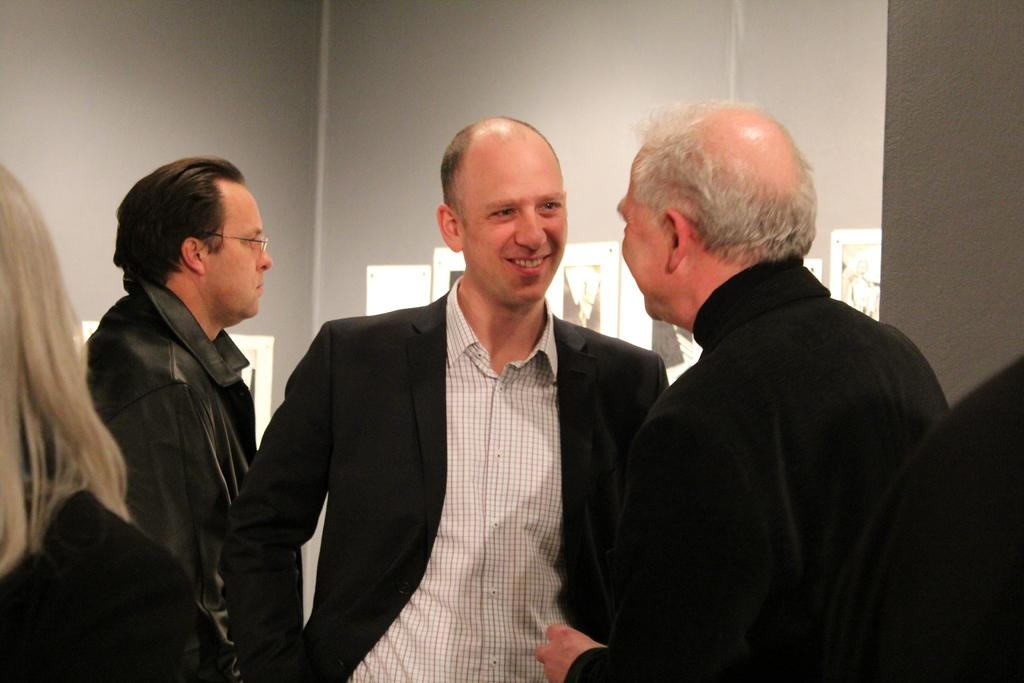What is happening in the image involving a group of people? There is a group of people standing in the image. What can be seen on the wall in the image? Papers are pinned to a wall in the image. What type of machine is being used by the hen in the image? There is no hen or machine present in the image. 